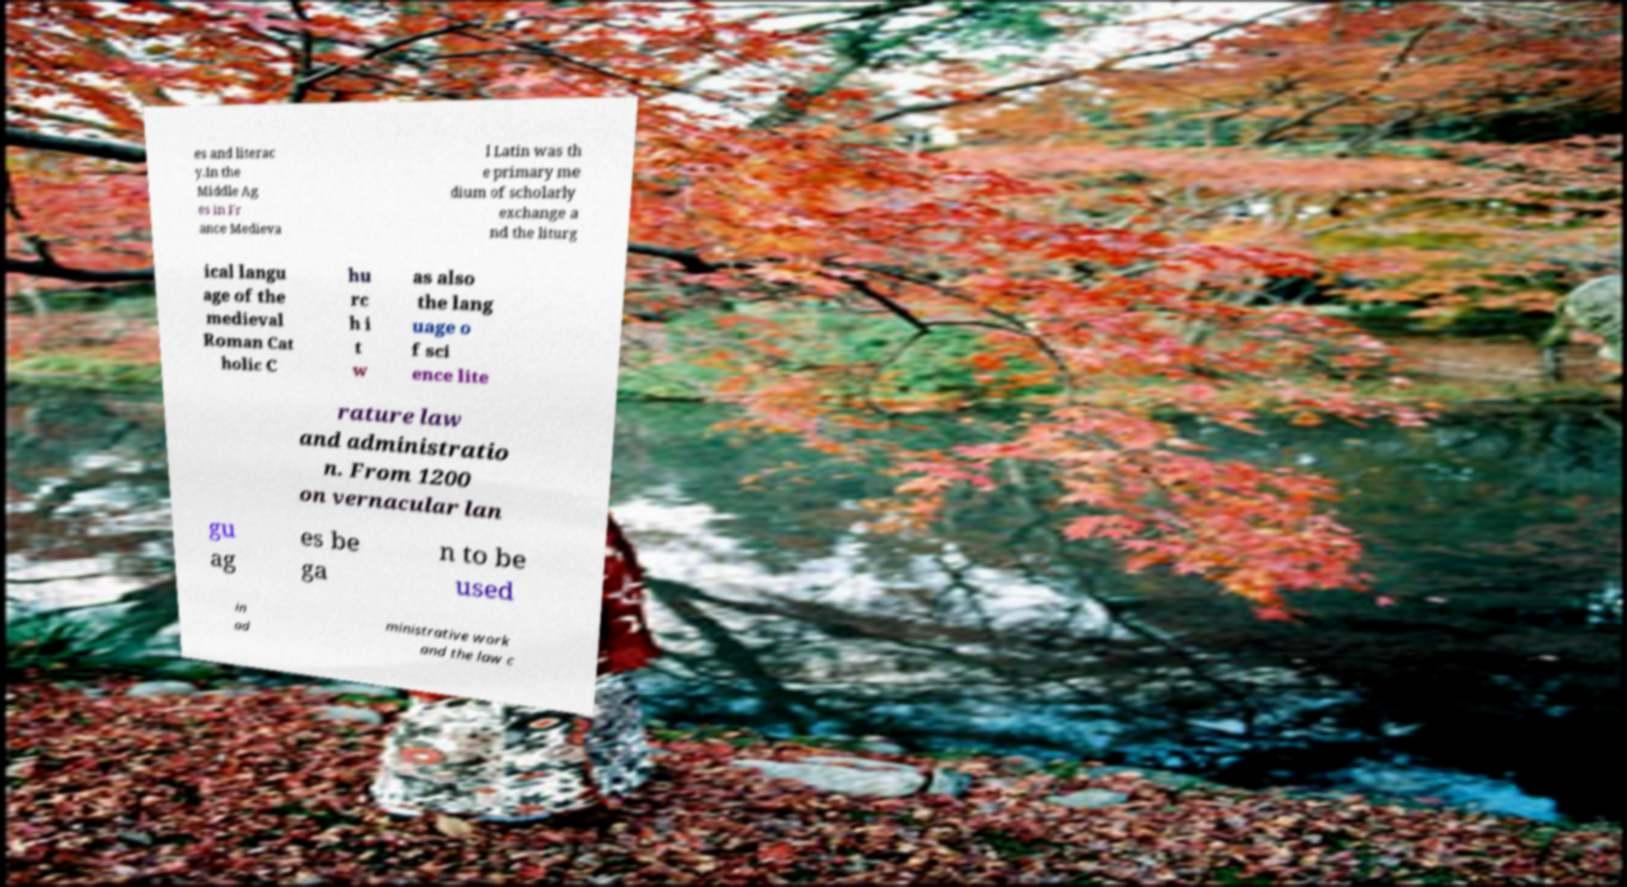Can you read and provide the text displayed in the image?This photo seems to have some interesting text. Can you extract and type it out for me? es and literac y.In the Middle Ag es in Fr ance Medieva l Latin was th e primary me dium of scholarly exchange a nd the liturg ical langu age of the medieval Roman Cat holic C hu rc h i t w as also the lang uage o f sci ence lite rature law and administratio n. From 1200 on vernacular lan gu ag es be ga n to be used in ad ministrative work and the law c 